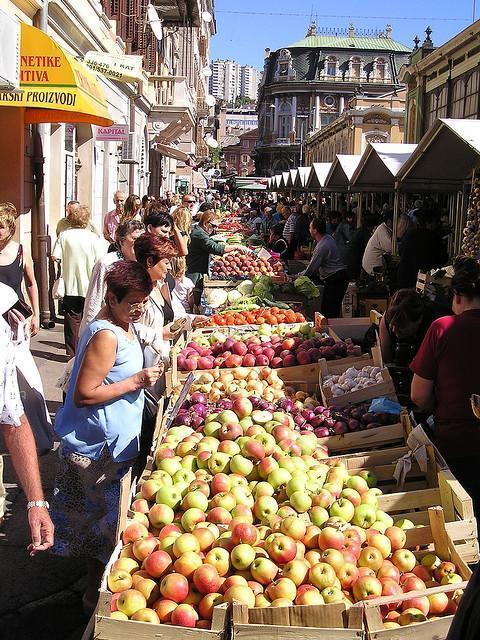Where does a shopper look to see how much a certain fruit costs?
Make your selection from the four choices given to correctly answer the question.
Options: Cardboard sign, tent flap, no where, vendors nametag. Cardboard sign. 